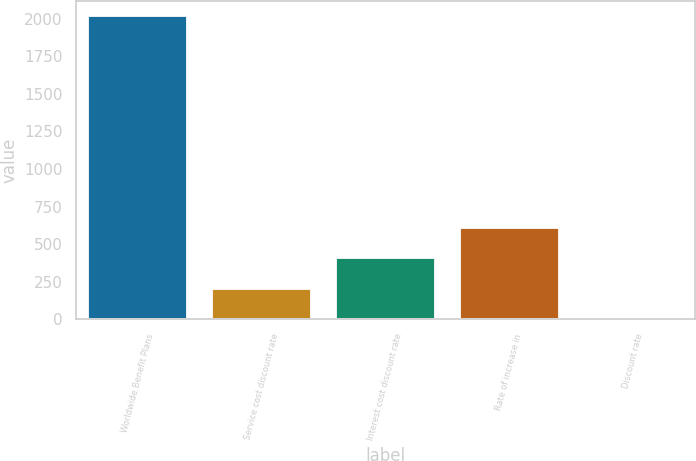Convert chart. <chart><loc_0><loc_0><loc_500><loc_500><bar_chart><fcel>Worldwide Benefit Plans<fcel>Service cost discount rate<fcel>Interest cost discount rate<fcel>Rate of increase in<fcel>Discount rate<nl><fcel>2017<fcel>204.67<fcel>406.04<fcel>607.41<fcel>3.3<nl></chart> 